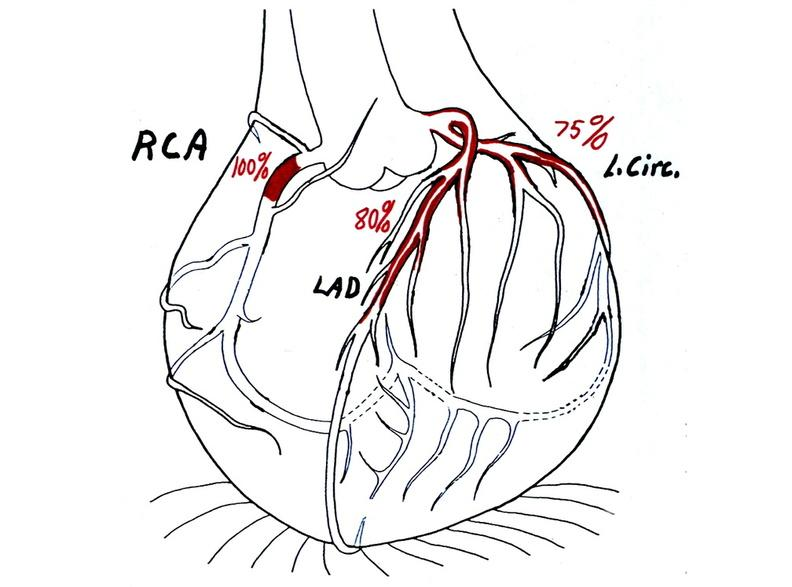does this image show coronary artery atherosclerosis diagram?
Answer the question using a single word or phrase. Yes 